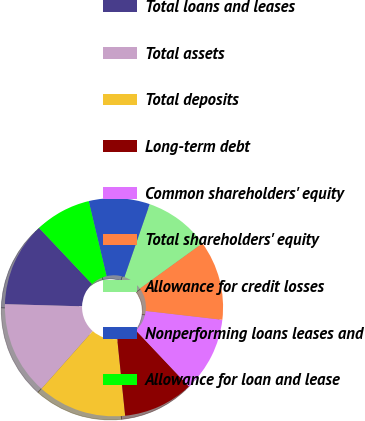Convert chart. <chart><loc_0><loc_0><loc_500><loc_500><pie_chart><fcel>Total loans and leases<fcel>Total assets<fcel>Total deposits<fcel>Long-term debt<fcel>Common shareholders' equity<fcel>Total shareholders' equity<fcel>Allowance for credit losses<fcel>Nonperforming loans leases and<fcel>Allowance for loan and lease<nl><fcel>12.5%<fcel>13.89%<fcel>13.19%<fcel>10.42%<fcel>11.11%<fcel>11.81%<fcel>9.72%<fcel>9.03%<fcel>8.33%<nl></chart> 